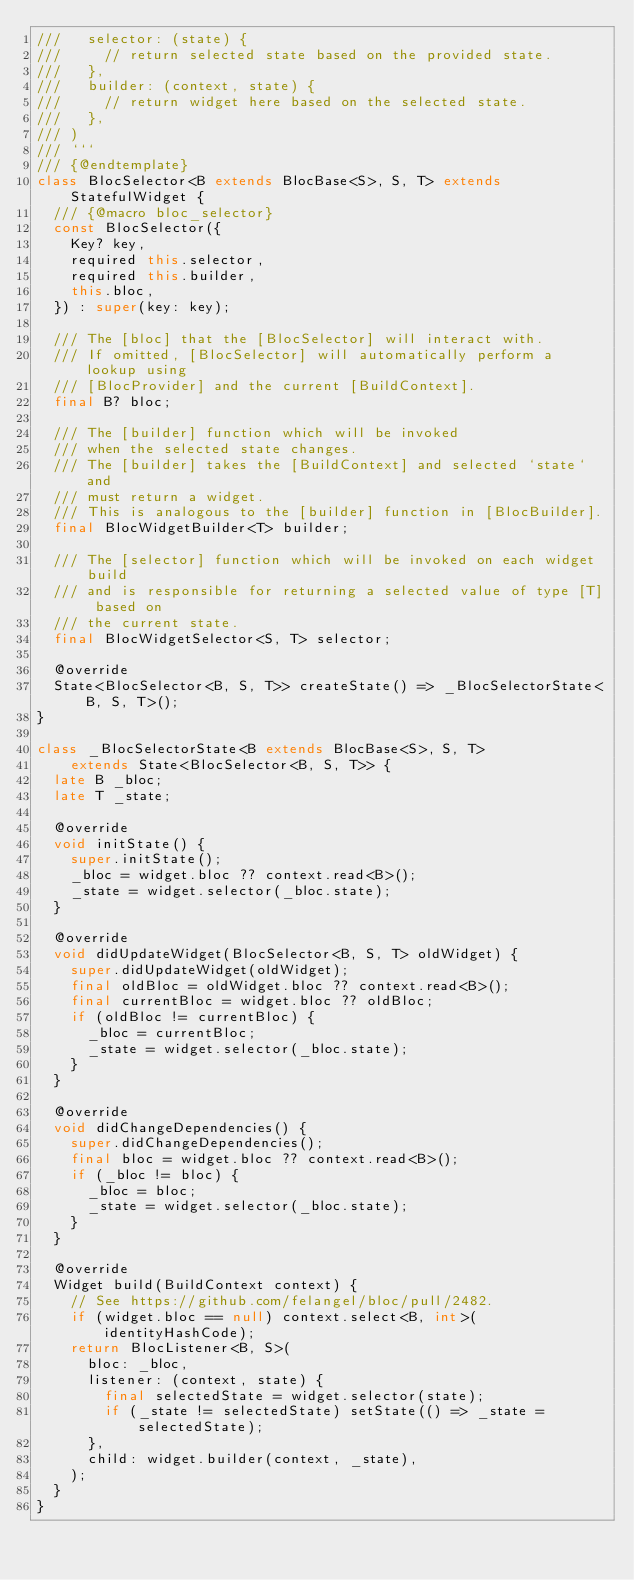<code> <loc_0><loc_0><loc_500><loc_500><_Dart_>///   selector: (state) {
///     // return selected state based on the provided state.
///   },
///   builder: (context, state) {
///     // return widget here based on the selected state.
///   },
/// )
/// ```
/// {@endtemplate}
class BlocSelector<B extends BlocBase<S>, S, T> extends StatefulWidget {
  /// {@macro bloc_selector}
  const BlocSelector({
    Key? key,
    required this.selector,
    required this.builder,
    this.bloc,
  }) : super(key: key);

  /// The [bloc] that the [BlocSelector] will interact with.
  /// If omitted, [BlocSelector] will automatically perform a lookup using
  /// [BlocProvider] and the current [BuildContext].
  final B? bloc;

  /// The [builder] function which will be invoked
  /// when the selected state changes.
  /// The [builder] takes the [BuildContext] and selected `state` and
  /// must return a widget.
  /// This is analogous to the [builder] function in [BlocBuilder].
  final BlocWidgetBuilder<T> builder;

  /// The [selector] function which will be invoked on each widget build
  /// and is responsible for returning a selected value of type [T] based on
  /// the current state.
  final BlocWidgetSelector<S, T> selector;

  @override
  State<BlocSelector<B, S, T>> createState() => _BlocSelectorState<B, S, T>();
}

class _BlocSelectorState<B extends BlocBase<S>, S, T>
    extends State<BlocSelector<B, S, T>> {
  late B _bloc;
  late T _state;

  @override
  void initState() {
    super.initState();
    _bloc = widget.bloc ?? context.read<B>();
    _state = widget.selector(_bloc.state);
  }

  @override
  void didUpdateWidget(BlocSelector<B, S, T> oldWidget) {
    super.didUpdateWidget(oldWidget);
    final oldBloc = oldWidget.bloc ?? context.read<B>();
    final currentBloc = widget.bloc ?? oldBloc;
    if (oldBloc != currentBloc) {
      _bloc = currentBloc;
      _state = widget.selector(_bloc.state);
    }
  }

  @override
  void didChangeDependencies() {
    super.didChangeDependencies();
    final bloc = widget.bloc ?? context.read<B>();
    if (_bloc != bloc) {
      _bloc = bloc;
      _state = widget.selector(_bloc.state);
    }
  }

  @override
  Widget build(BuildContext context) {
    // See https://github.com/felangel/bloc/pull/2482.
    if (widget.bloc == null) context.select<B, int>(identityHashCode);
    return BlocListener<B, S>(
      bloc: _bloc,
      listener: (context, state) {
        final selectedState = widget.selector(state);
        if (_state != selectedState) setState(() => _state = selectedState);
      },
      child: widget.builder(context, _state),
    );
  }
}
</code> 